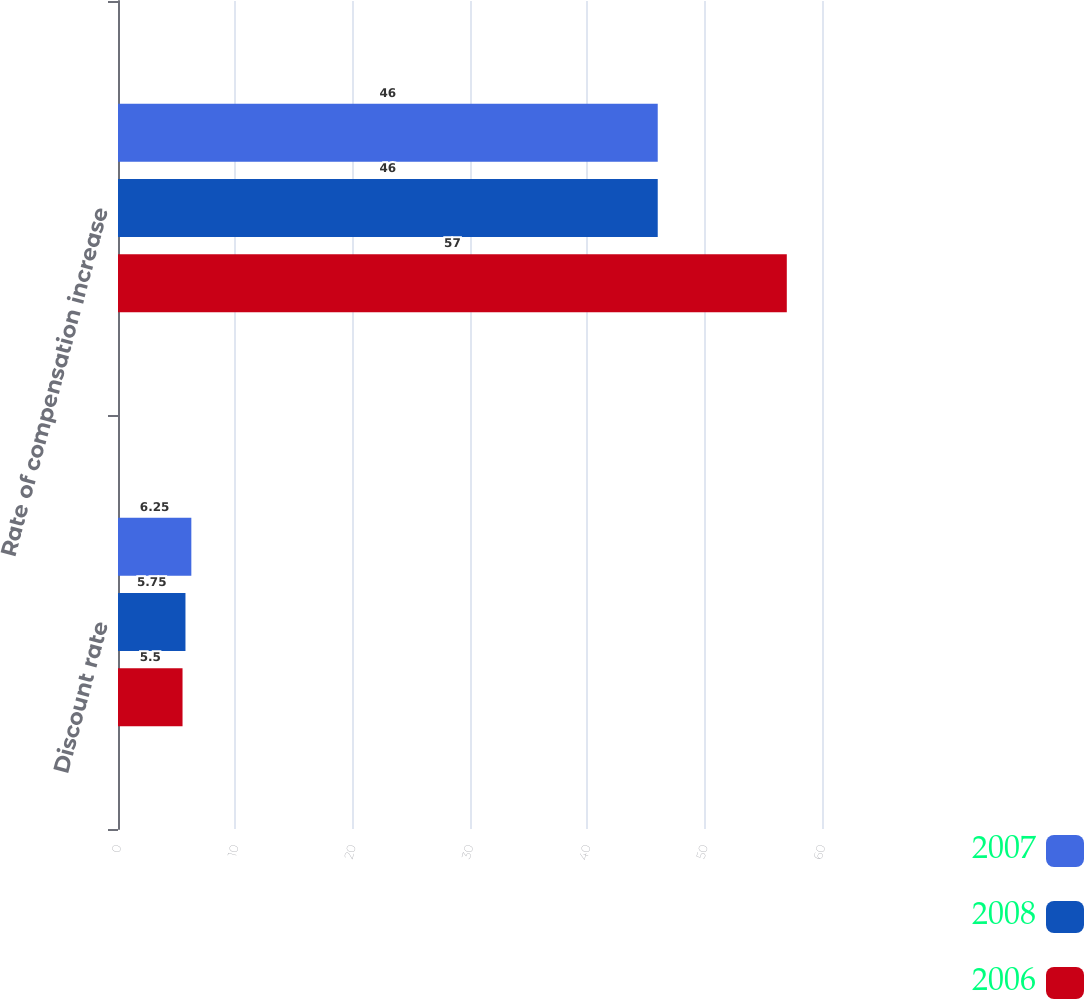Convert chart to OTSL. <chart><loc_0><loc_0><loc_500><loc_500><stacked_bar_chart><ecel><fcel>Discount rate<fcel>Rate of compensation increase<nl><fcel>2007<fcel>6.25<fcel>46<nl><fcel>2008<fcel>5.75<fcel>46<nl><fcel>2006<fcel>5.5<fcel>57<nl></chart> 